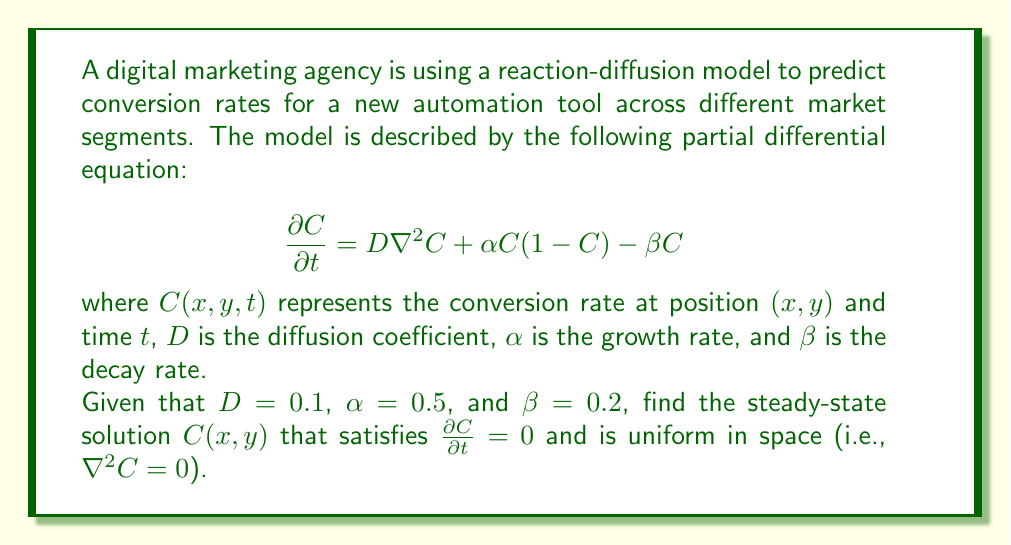Teach me how to tackle this problem. To solve this problem, we follow these steps:

1) The steady-state solution is found by setting $\frac{\partial C}{\partial t}=0$. This gives us:

   $$0 = D\nabla^2C + \alpha C(1-C) - \beta C$$

2) We're told that the solution is uniform in space, meaning $\nabla^2C=0$. Applying this:

   $$0 = \alpha C(1-C) - \beta C$$

3) Factor out $C$:

   $$0 = C(\alpha(1-C) - \beta)$$

4) This equation is satisfied when either $C=0$ or when $\alpha(1-C) - \beta = 0$. Let's solve the second case:

   $$\alpha(1-C) - \beta = 0$$
   $$\alpha - \alpha C - \beta = 0$$
   $$\alpha - \beta = \alpha C$$
   $$C = \frac{\alpha - \beta}{\alpha}$$

5) Now, let's substitute the given values: $\alpha=0.5$ and $\beta=0.2$:

   $$C = \frac{0.5 - 0.2}{0.5} = \frac{0.3}{0.5} = 0.6$$

6) We need to check if this solution is stable. The solution $C=0$ is unstable because any small perturbation will grow due to the positive growth term when $C$ is small. Therefore, the non-zero solution we found is the stable steady-state solution.

Thus, the uniform steady-state solution is $C(x,y) = 0.6$.
Answer: $C(x,y) = 0.6$ 